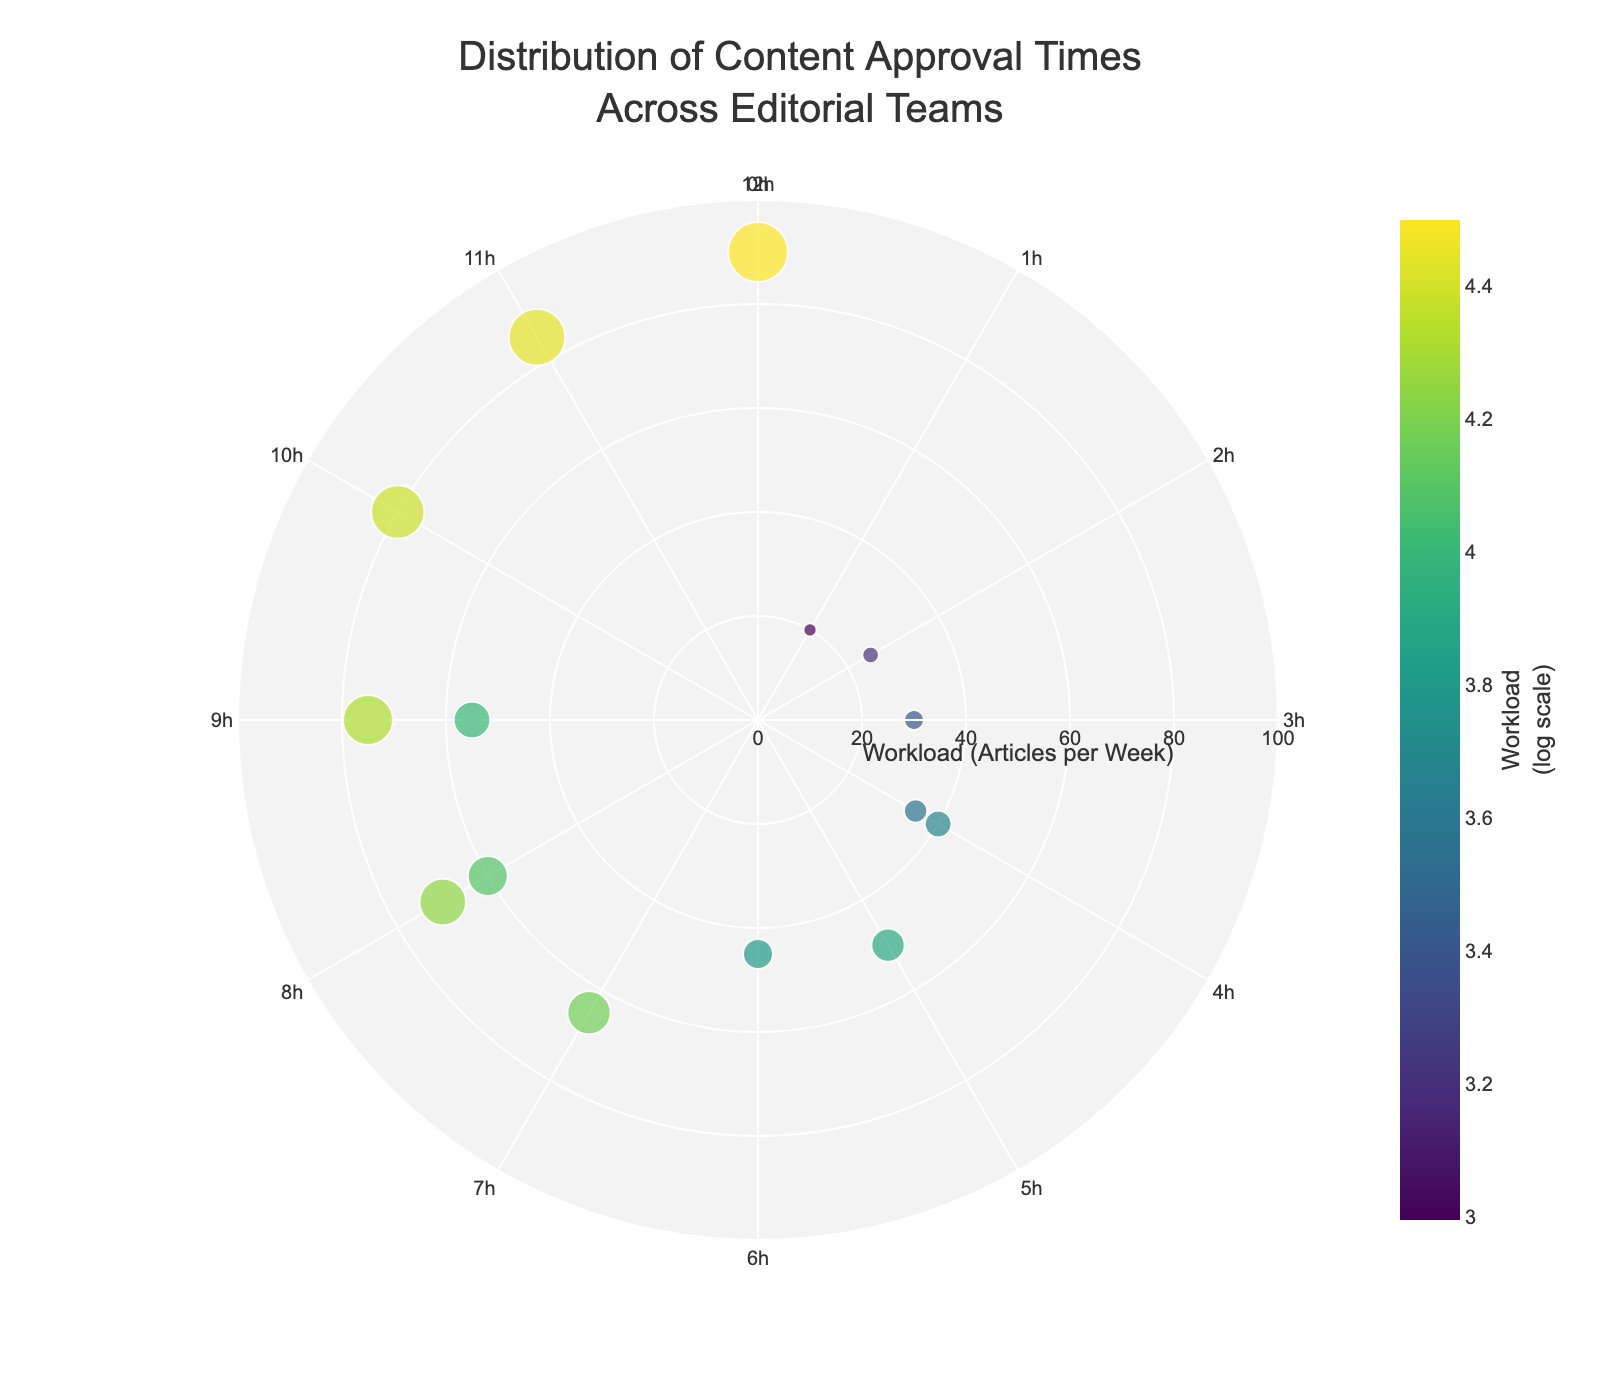What's the title of the figure? The title is positioned at the top center of the figure and reads "Distribution of Content Approval Times Across Editorial Teams".
Answer: Distribution of Content Approval Times Across Editorial Teams Which team has the highest workload? In the figure, the radial axis represents the workload in articles per week. The team with the point farthest from the center represents the highest workload, which is Editorial-Team-D at 90 articles per week.
Answer: Editorial-Team-D How many teams have an approval time of exactly 6 hours? The angular axis of the figure is marked in hours, and we look for data points at the 180-degree mark, which corresponds to 6 hours. Only one team (Editorial-Team-E) resides there.
Answer: 1 What is the range of workloads among the editorial teams? The minimum workload is at Editorial-Team-O with 20 articles per week, and the maximum is at Editorial-Team-D with 90 articles per week. The range is calculated as 90 - 20.
Answer: 70 Which team has the shortest approval time, and what is this time? The shortest approval time corresponds to the point closest to the 0-degree mark, which belongs to Editorial-Team-O with an approval time of 1 hour.
Answer: Editorial-Team-O with 1 hour Which team has the lowest workload, and what is its approval time? The team with the lowest workload is found by locating the point closest to the center, which is Editorial-Team-O with a workload of 20 articles per week and an approval time of 1 hour.
Answer: Editorial-Team-O with a workload of 20 articles per week and an approval time of 1 hour How many teams have an approval time greater than 8 hours? The angular axis can be checked for values above 240 degrees, which correspond to approval times greater than 8 hours. These teams are Editorial-Team-D, Editorial-Team-I, Editorial-Team-M, and Editorial-Team-N. There are four such teams.
Answer: 4 Which team has both high workload and high approval time? The team with one of the highest workloads and high approval times (above 8 hours) can be identified. Editorial-Team-D has a workload of 90 and an approval time of 12 hours.
Answer: Editorial-Team-D Compare the approval times of Editorial-Team-B and Editorial-Team-H. Which team has a longer approval time? Editorial-Team-B has an approval time of 8 hours, while Editorial-Team-H has an approval time of 10 hours. By comparison, Editorial-Team-H has the longer approval time.
Answer: Editorial-Team-H Which team has the smallest size marker? The marker size correlates with the workload, and the smallest marker closely matches Editorial-Team-O, given its workload of 20 articles per week and small marker relative to others.
Answer: Editorial-Team-O 